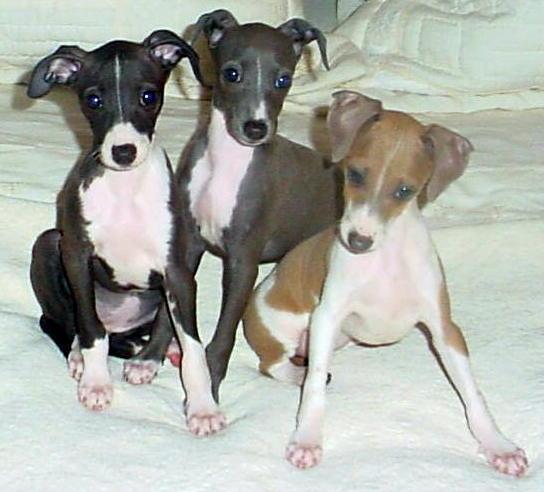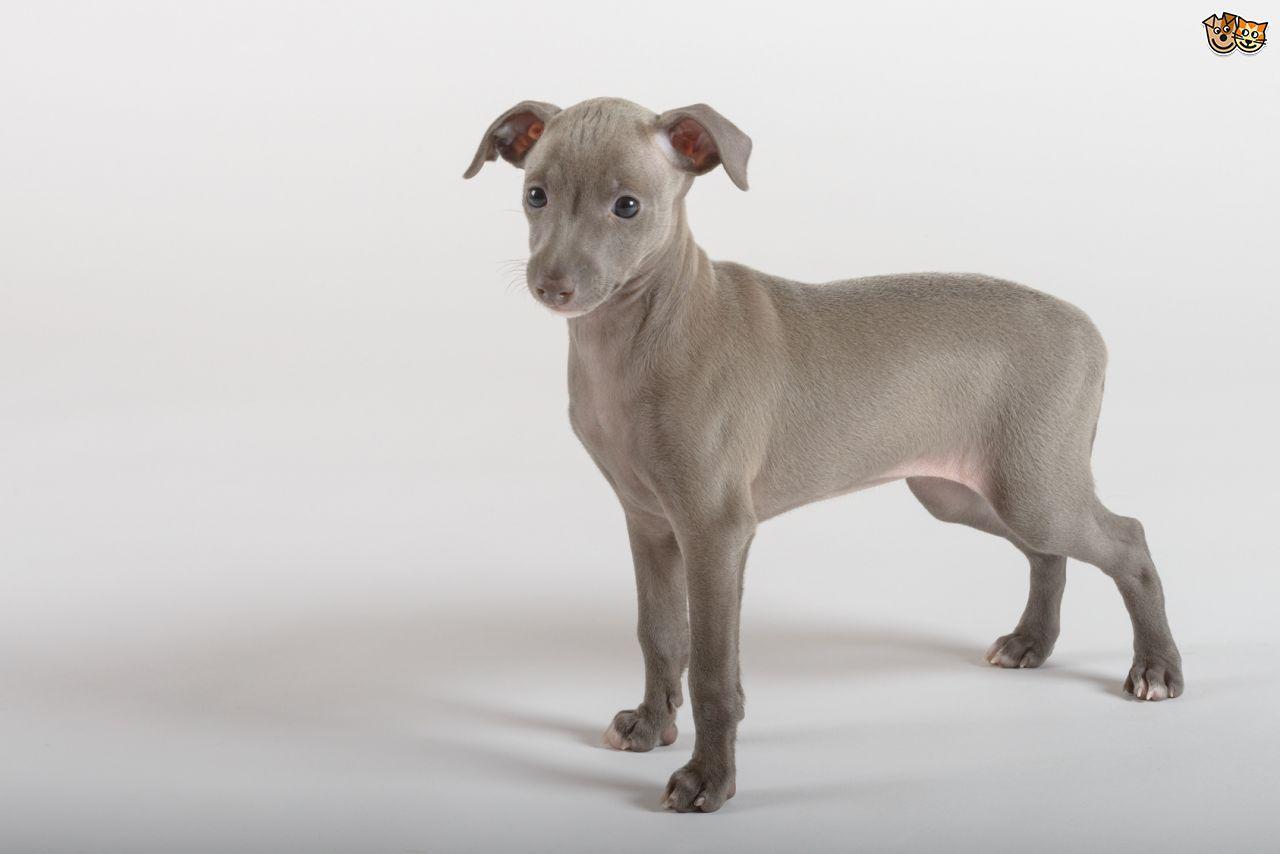The first image is the image on the left, the second image is the image on the right. Assess this claim about the two images: "All four feet of the dog in the image on the right can be seen touching the ground.". Correct or not? Answer yes or no. Yes. 